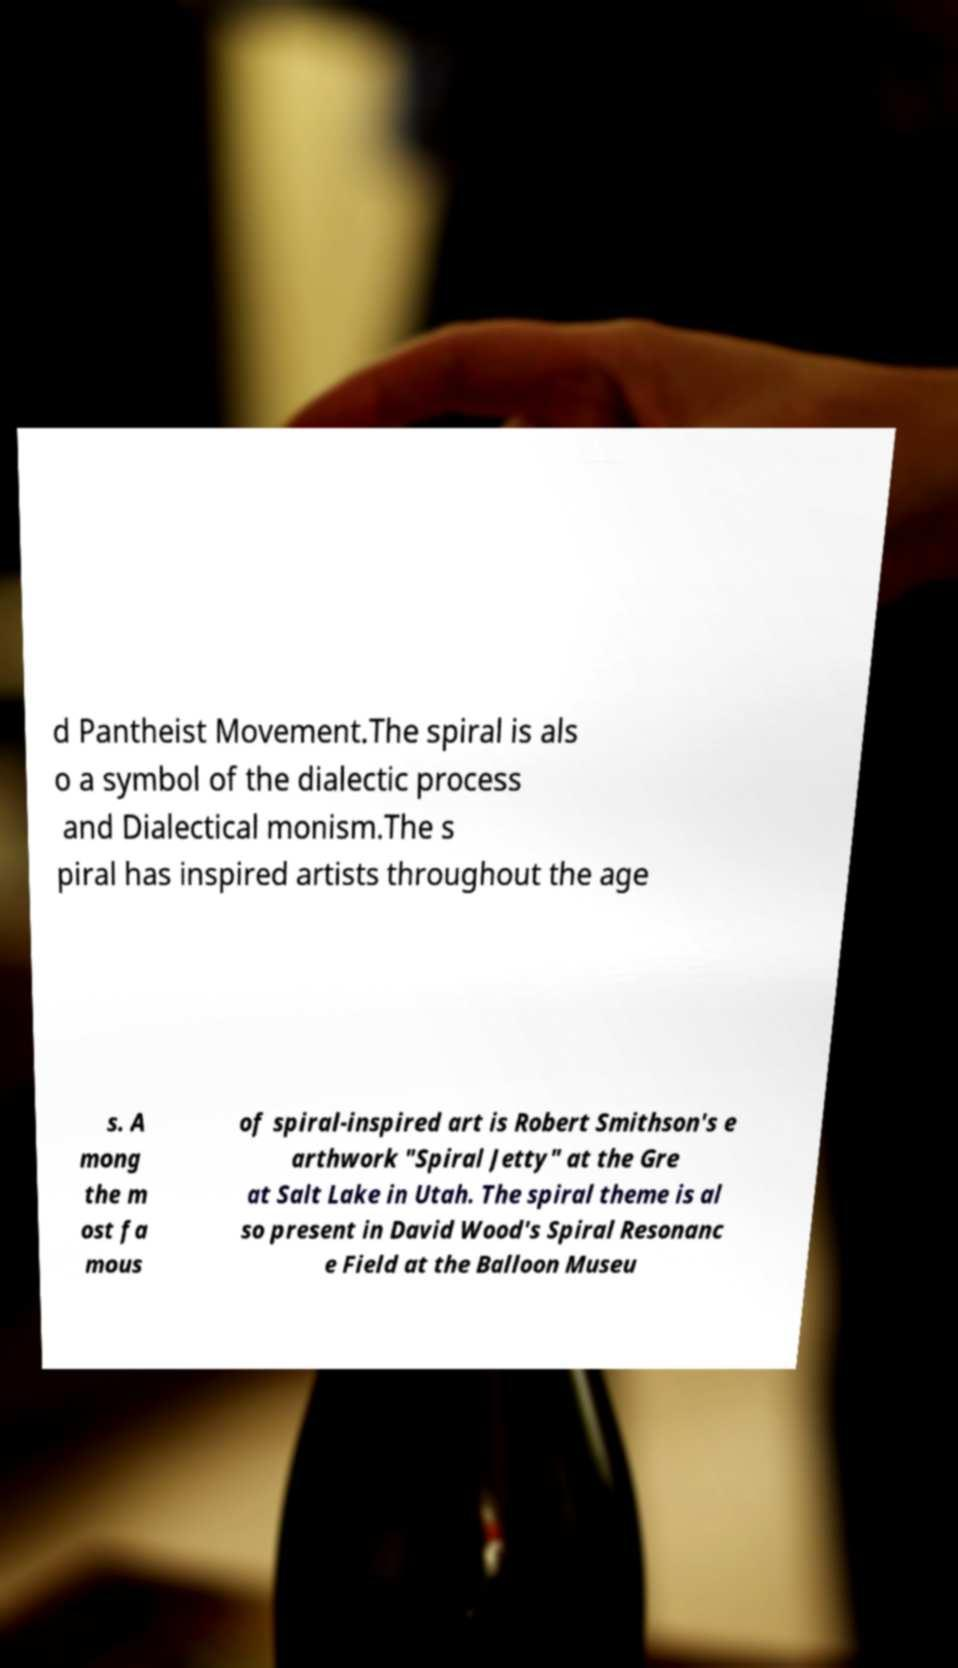There's text embedded in this image that I need extracted. Can you transcribe it verbatim? d Pantheist Movement.The spiral is als o a symbol of the dialectic process and Dialectical monism.The s piral has inspired artists throughout the age s. A mong the m ost fa mous of spiral-inspired art is Robert Smithson's e arthwork "Spiral Jetty" at the Gre at Salt Lake in Utah. The spiral theme is al so present in David Wood's Spiral Resonanc e Field at the Balloon Museu 